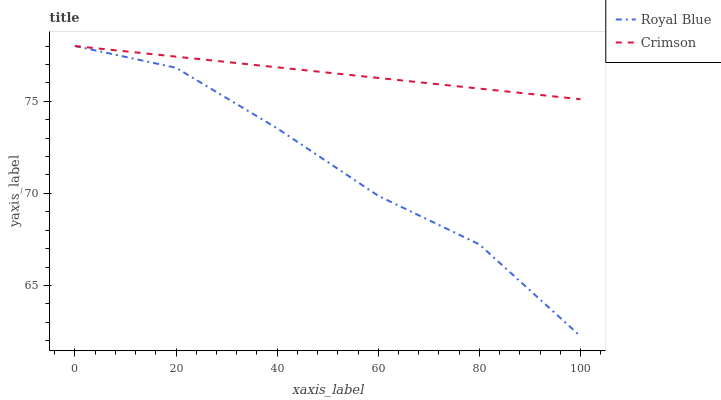Does Royal Blue have the minimum area under the curve?
Answer yes or no. Yes. Does Crimson have the maximum area under the curve?
Answer yes or no. Yes. Does Royal Blue have the maximum area under the curve?
Answer yes or no. No. Is Crimson the smoothest?
Answer yes or no. Yes. Is Royal Blue the roughest?
Answer yes or no. Yes. Is Royal Blue the smoothest?
Answer yes or no. No. Does Royal Blue have the highest value?
Answer yes or no. Yes. 